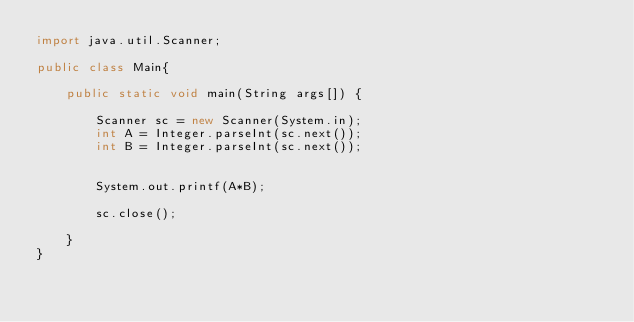<code> <loc_0><loc_0><loc_500><loc_500><_Java_>import java.util.Scanner;

public class Main{

    public static void main(String args[]) {

        Scanner sc = new Scanner(System.in);
        int A = Integer.parseInt(sc.next());
        int B = Integer.parseInt(sc.next());
       
      
        System.out.printf(A*B);

        sc.close();

    }
}</code> 